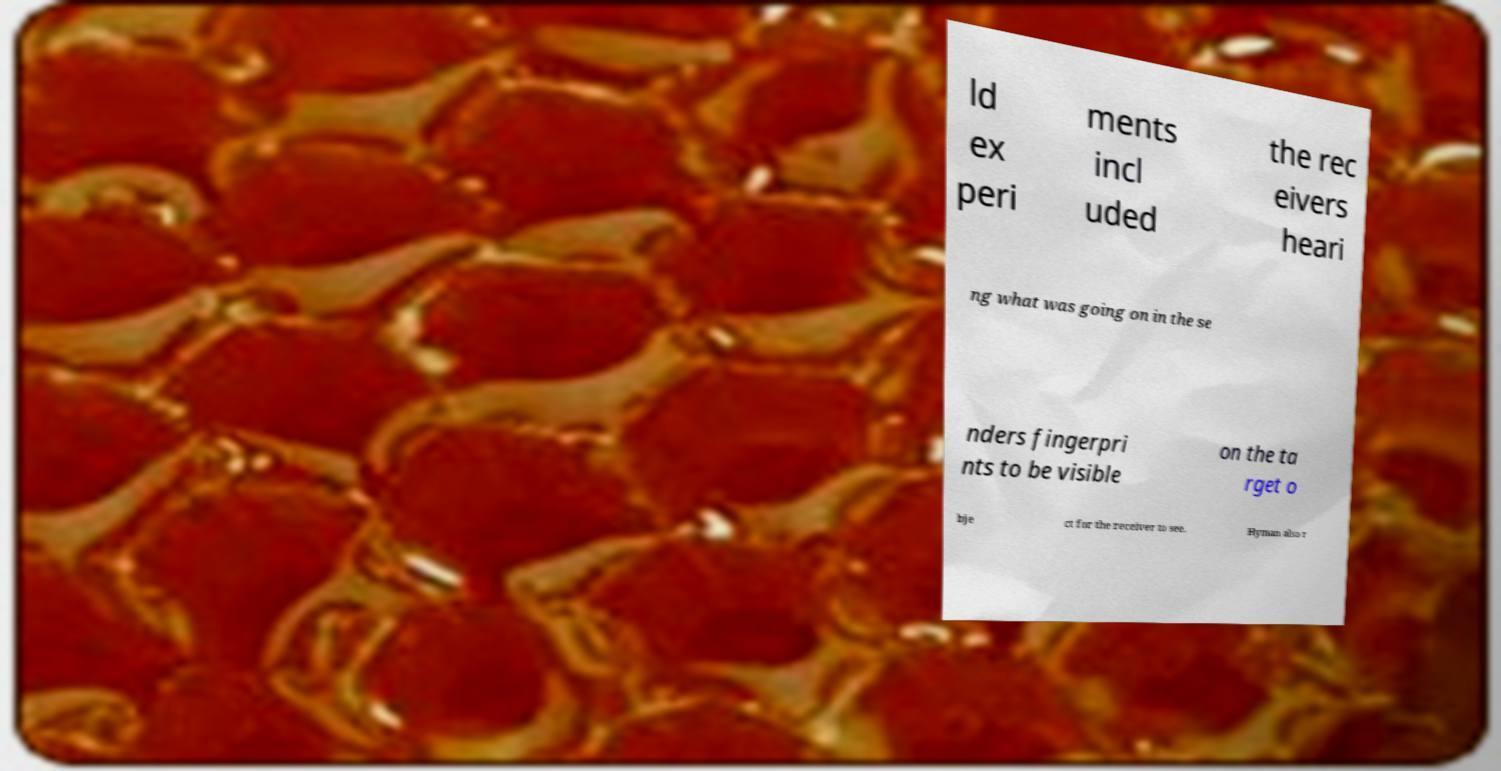Can you accurately transcribe the text from the provided image for me? ld ex peri ments incl uded the rec eivers heari ng what was going on in the se nders fingerpri nts to be visible on the ta rget o bje ct for the receiver to see. Hyman also r 